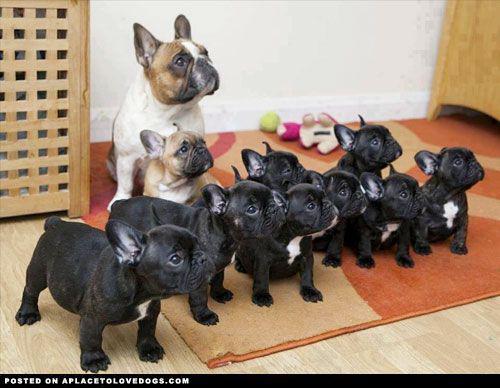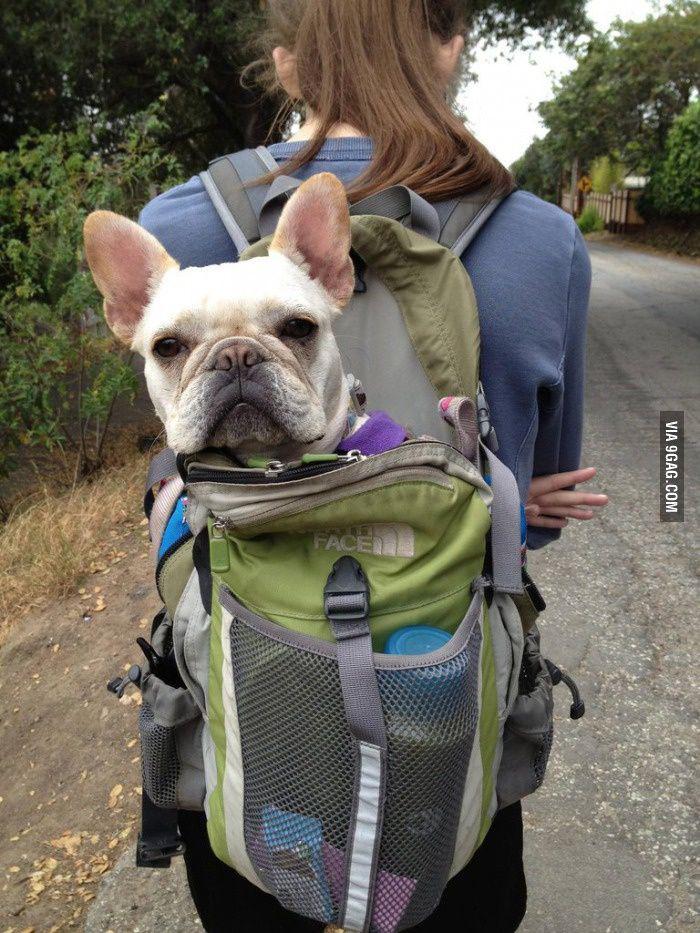The first image is the image on the left, the second image is the image on the right. For the images shown, is this caption "There is only one dog in one of the images." true? Answer yes or no. Yes. The first image is the image on the left, the second image is the image on the right. For the images displayed, is the sentence "The left image contains no more than three dogs." factually correct? Answer yes or no. No. 